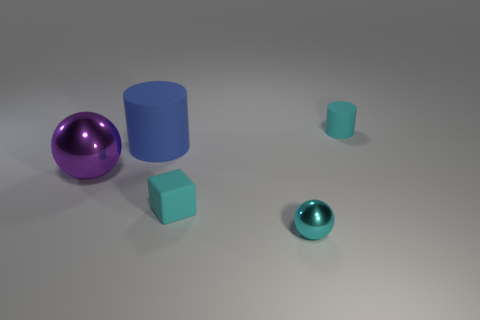Is there a light source in the image, and if so, how can we tell? Yes, there is a light source in the image even though it's not directly visible. We can infer its presence from the shadows cast by the objects on the ground and the specular highlights on the shiny surfaces of the spheres. The direction of the shadows suggests the light is coming from the top left side of the frame. 